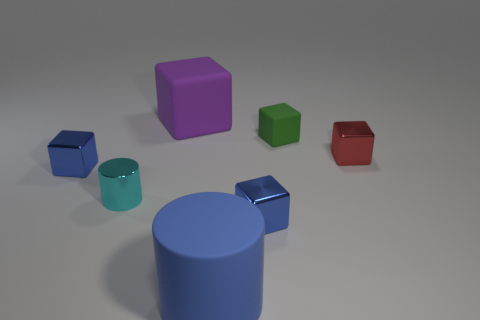Add 2 tiny purple cylinders. How many objects exist? 9 Subtract all red cubes. How many cubes are left? 4 Subtract all purple cylinders. How many blue cubes are left? 2 Subtract all cyan cylinders. How many cylinders are left? 1 Subtract all cubes. How many objects are left? 2 Subtract 1 blocks. How many blocks are left? 4 Subtract all cyan cubes. Subtract all purple cylinders. How many cubes are left? 5 Subtract all tiny blue objects. Subtract all big matte blocks. How many objects are left? 4 Add 7 green rubber blocks. How many green rubber blocks are left? 8 Add 1 small brown metal balls. How many small brown metal balls exist? 1 